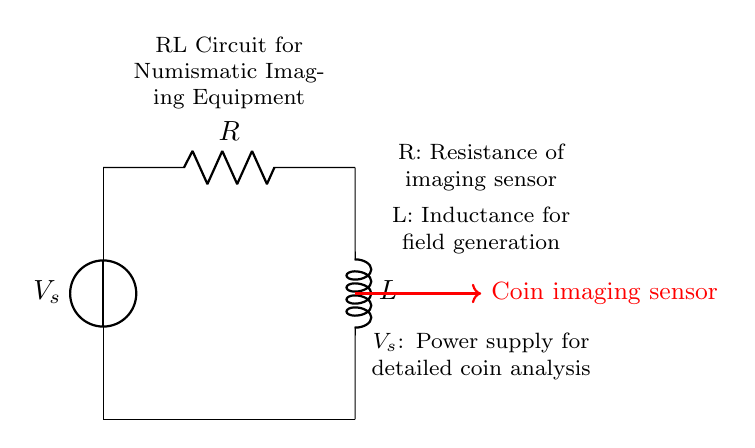What are the main components in this circuit? The circuit consists of a voltage source, a resistor, and an inductor. These components are connected in a series arrangement.
Answer: Voltage source, resistor, inductor What does "R" represent in this circuit? "R" stands for the resistance of the imaging sensor in the numismatic imaging equipment. The label indicates its role in the circuit.
Answer: Resistance of imaging sensor What does "L" stand for in this circuit? "L" represents the inductance used for field generation in the circuit, indicating how it affects the magnetic field for the imaging sensor.
Answer: Inductance for field generation What is the purpose of the voltage source "V_s"? The voltage source "V_s" provides the necessary power supply for detailed coin analysis in the imaging equipment, ensuring it operates effectively.
Answer: Power supply for detailed coin analysis How are the components connected in this RL circuit? The components are arranged in a series connection, starting from the voltage source to the resistor and then to the inductor before returning to the source.
Answer: Series connection What effect does the inductor have on the circuit operation? The inductor influences the current flow and helps to stabilize it by opposing changes in current, which is important for accurate imaging in numismatics.
Answer: Current stabilization What type of circuit is being represented? This circuit is an RL circuit, which consists of a resistor and an inductor connected in series, commonly used for applications involving inductance and resistance.
Answer: RL circuit 